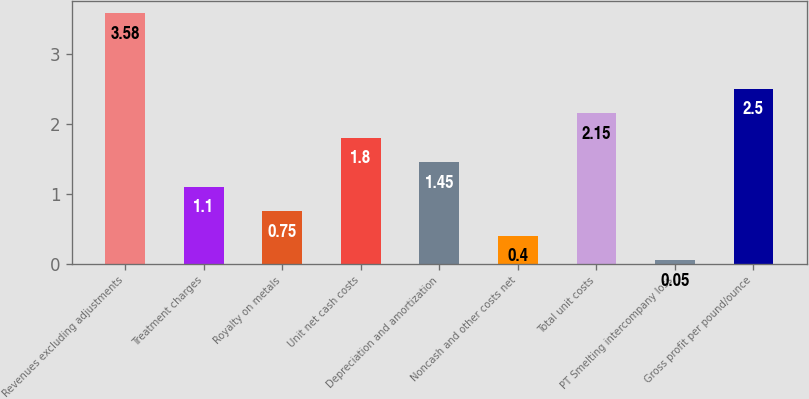Convert chart. <chart><loc_0><loc_0><loc_500><loc_500><bar_chart><fcel>Revenues excluding adjustments<fcel>Treatment charges<fcel>Royalty on metals<fcel>Unit net cash costs<fcel>Depreciation and amortization<fcel>Noncash and other costs net<fcel>Total unit costs<fcel>PT Smelting intercompany loss<fcel>Gross profit per pound/ounce<nl><fcel>3.58<fcel>1.1<fcel>0.75<fcel>1.8<fcel>1.45<fcel>0.4<fcel>2.15<fcel>0.05<fcel>2.5<nl></chart> 